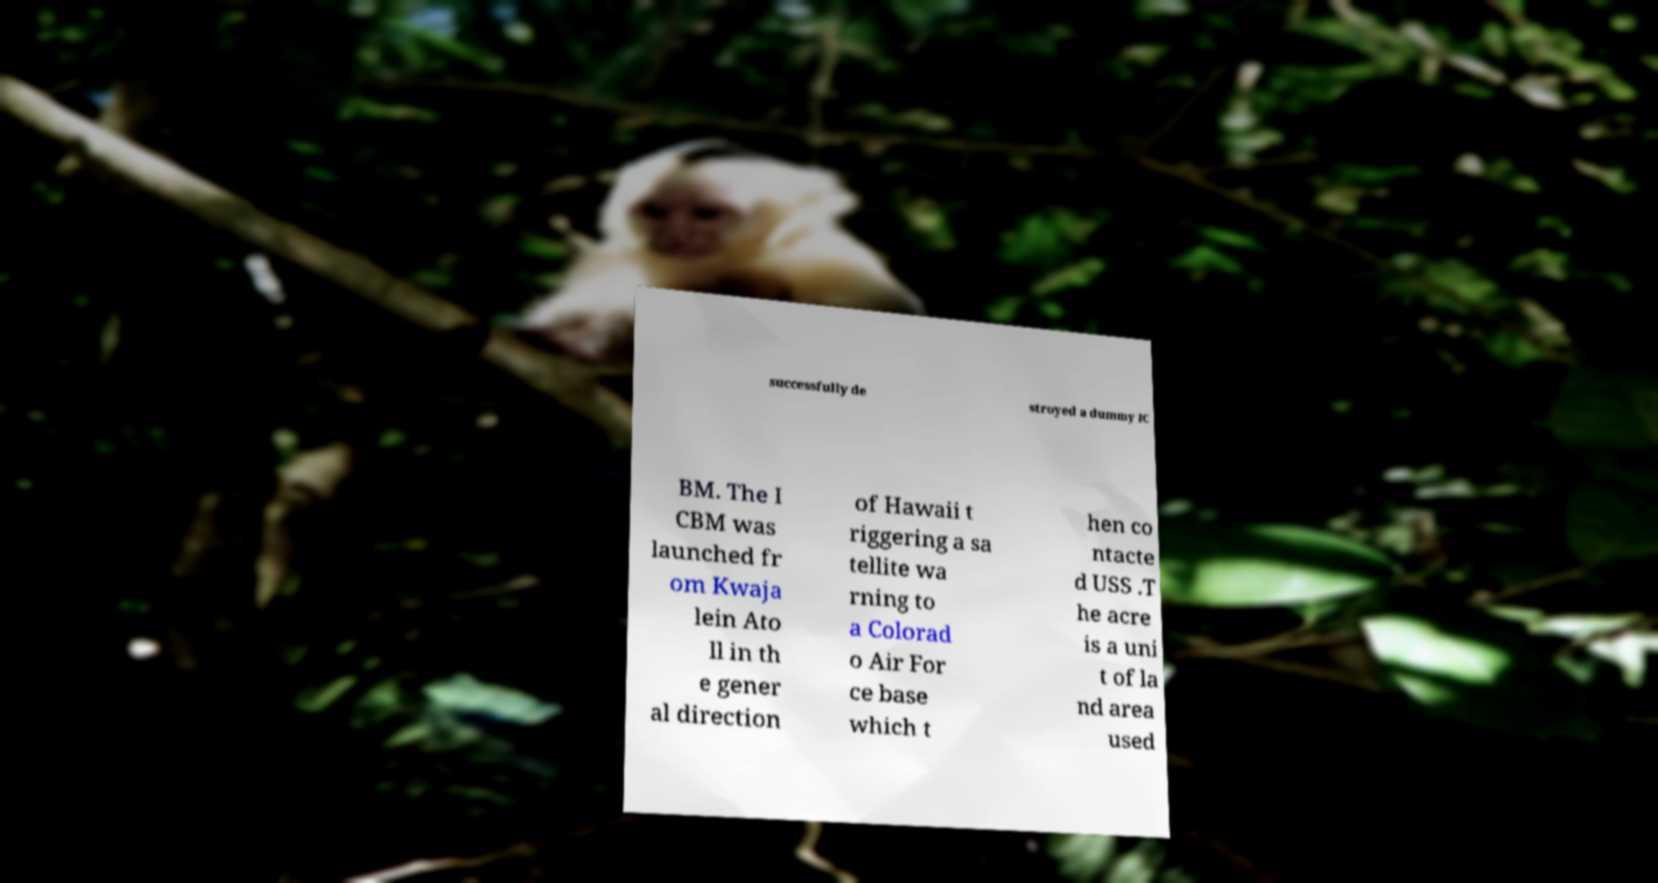Please identify and transcribe the text found in this image. successfully de stroyed a dummy IC BM. The I CBM was launched fr om Kwaja lein Ato ll in th e gener al direction of Hawaii t riggering a sa tellite wa rning to a Colorad o Air For ce base which t hen co ntacte d USS .T he acre is a uni t of la nd area used 